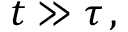Convert formula to latex. <formula><loc_0><loc_0><loc_500><loc_500>t \gg \tau \, ,</formula> 